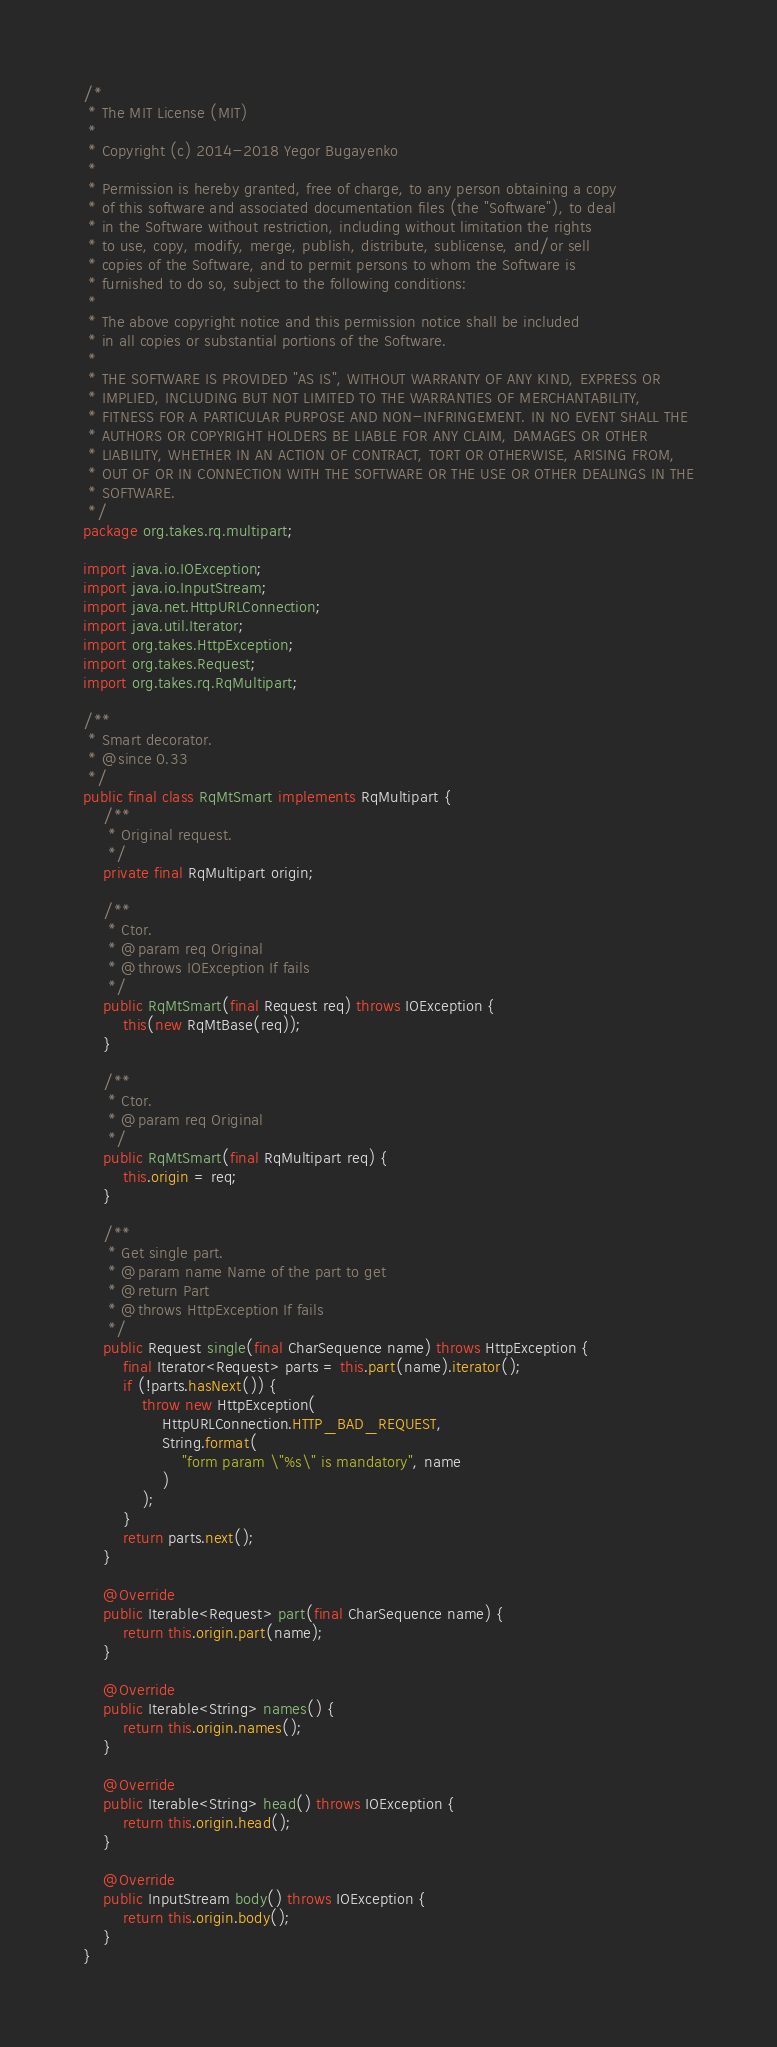<code> <loc_0><loc_0><loc_500><loc_500><_Java_>/*
 * The MIT License (MIT)
 *
 * Copyright (c) 2014-2018 Yegor Bugayenko
 *
 * Permission is hereby granted, free of charge, to any person obtaining a copy
 * of this software and associated documentation files (the "Software"), to deal
 * in the Software without restriction, including without limitation the rights
 * to use, copy, modify, merge, publish, distribute, sublicense, and/or sell
 * copies of the Software, and to permit persons to whom the Software is
 * furnished to do so, subject to the following conditions:
 *
 * The above copyright notice and this permission notice shall be included
 * in all copies or substantial portions of the Software.
 *
 * THE SOFTWARE IS PROVIDED "AS IS", WITHOUT WARRANTY OF ANY KIND, EXPRESS OR
 * IMPLIED, INCLUDING BUT NOT LIMITED TO THE WARRANTIES OF MERCHANTABILITY,
 * FITNESS FOR A PARTICULAR PURPOSE AND NON-INFRINGEMENT. IN NO EVENT SHALL THE
 * AUTHORS OR COPYRIGHT HOLDERS BE LIABLE FOR ANY CLAIM, DAMAGES OR OTHER
 * LIABILITY, WHETHER IN AN ACTION OF CONTRACT, TORT OR OTHERWISE, ARISING FROM,
 * OUT OF OR IN CONNECTION WITH THE SOFTWARE OR THE USE OR OTHER DEALINGS IN THE
 * SOFTWARE.
 */
package org.takes.rq.multipart;

import java.io.IOException;
import java.io.InputStream;
import java.net.HttpURLConnection;
import java.util.Iterator;
import org.takes.HttpException;
import org.takes.Request;
import org.takes.rq.RqMultipart;

/**
 * Smart decorator.
 * @since 0.33
 */
public final class RqMtSmart implements RqMultipart {
    /**
     * Original request.
     */
    private final RqMultipart origin;

    /**
     * Ctor.
     * @param req Original
     * @throws IOException If fails
     */
    public RqMtSmart(final Request req) throws IOException {
        this(new RqMtBase(req));
    }

    /**
     * Ctor.
     * @param req Original
     */
    public RqMtSmart(final RqMultipart req) {
        this.origin = req;
    }

    /**
     * Get single part.
     * @param name Name of the part to get
     * @return Part
     * @throws HttpException If fails
     */
    public Request single(final CharSequence name) throws HttpException {
        final Iterator<Request> parts = this.part(name).iterator();
        if (!parts.hasNext()) {
            throw new HttpException(
                HttpURLConnection.HTTP_BAD_REQUEST,
                String.format(
                    "form param \"%s\" is mandatory", name
                )
            );
        }
        return parts.next();
    }

    @Override
    public Iterable<Request> part(final CharSequence name) {
        return this.origin.part(name);
    }

    @Override
    public Iterable<String> names() {
        return this.origin.names();
    }

    @Override
    public Iterable<String> head() throws IOException {
        return this.origin.head();
    }

    @Override
    public InputStream body() throws IOException {
        return this.origin.body();
    }
}
</code> 